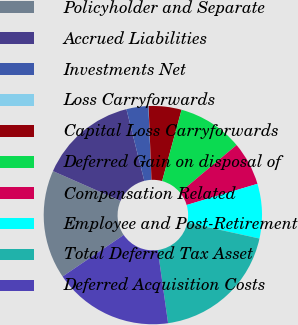Convert chart to OTSL. <chart><loc_0><loc_0><loc_500><loc_500><pie_chart><fcel>Policyholder and Separate<fcel>Accrued Liabilities<fcel>Investments Net<fcel>Loss Carryforwards<fcel>Capital Loss Carryforwards<fcel>Deferred Gain on disposal of<fcel>Compensation Related<fcel>Employee and Post-Retirement<fcel>Total Deferred Tax Asset<fcel>Deferred Acquisition Costs<nl><fcel>16.11%<fcel>14.5%<fcel>3.25%<fcel>0.03%<fcel>4.85%<fcel>9.68%<fcel>6.46%<fcel>8.07%<fcel>19.33%<fcel>17.72%<nl></chart> 